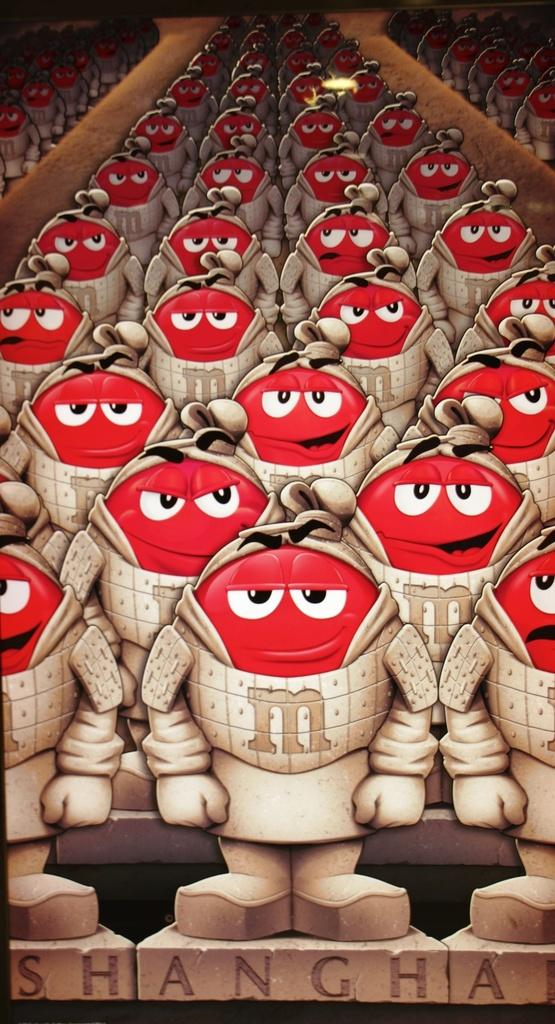What type of images are present in the picture? There are cartoon images in the picture. Can you describe the nature of the picture? The image appears to be animated. Is there any text present in the image? Yes, there is text at the bottom of the image. How far away is the sign from the duck in the image? There is no sign or duck present in the image. 